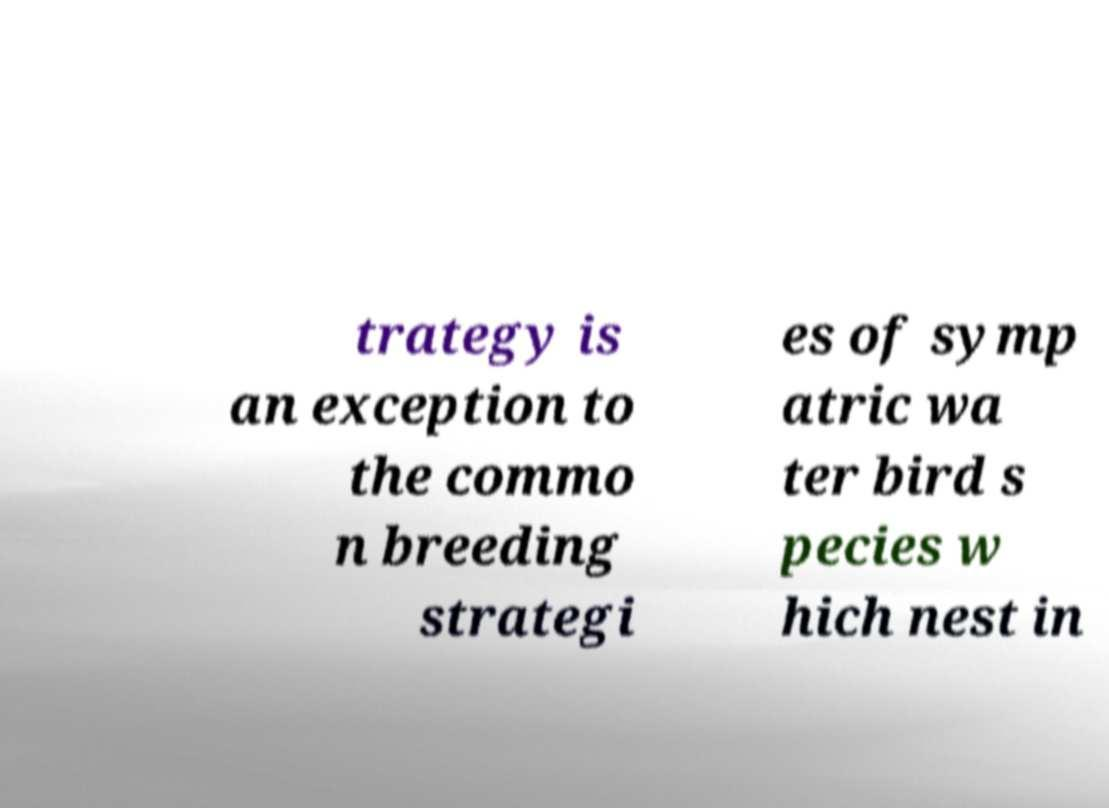There's text embedded in this image that I need extracted. Can you transcribe it verbatim? trategy is an exception to the commo n breeding strategi es of symp atric wa ter bird s pecies w hich nest in 